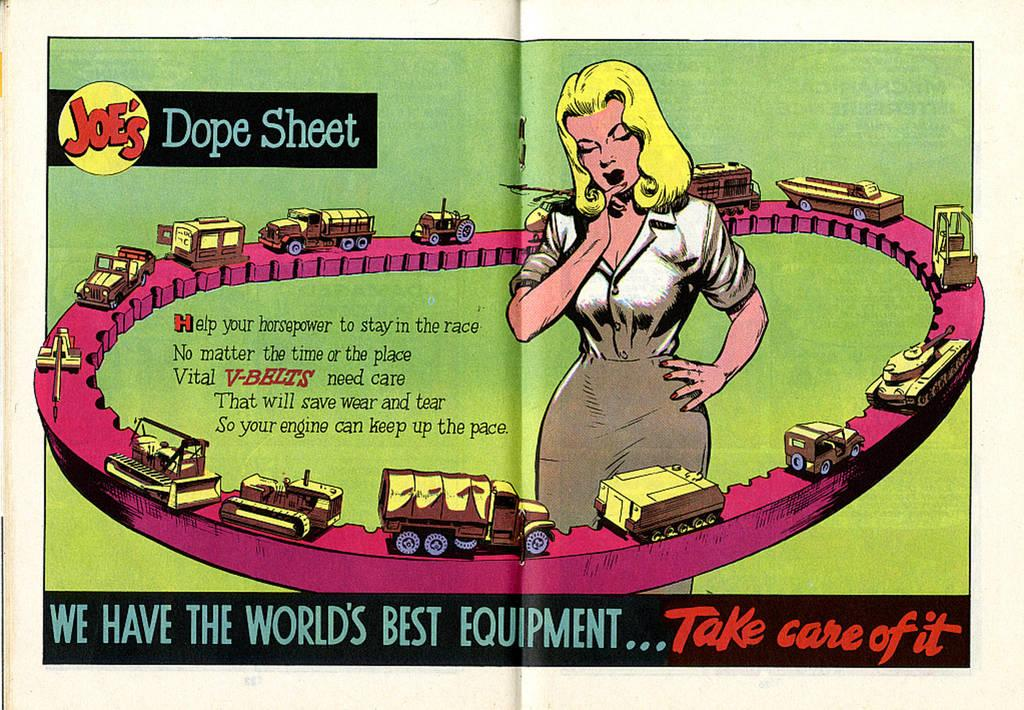Provide a one-sentence caption for the provided image. A magazine centerfold is open displaying a colorful cartoon called Joe's Dope Sheet. 